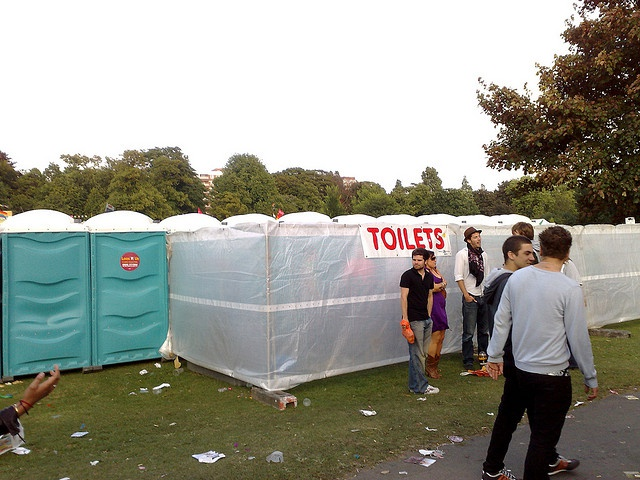Describe the objects in this image and their specific colors. I can see people in white, black, darkgray, and gray tones, toilet in white and teal tones, toilet in white and teal tones, people in white, black, gray, and maroon tones, and people in white, black, lightgray, darkgray, and gray tones in this image. 